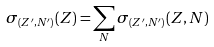Convert formula to latex. <formula><loc_0><loc_0><loc_500><loc_500>\sigma _ { ( Z ^ { \prime } , N ^ { \prime } ) } ( Z ) = \sum _ { N } { \sigma _ { ( Z ^ { \prime } , N ^ { \prime } ) } ( Z , N ) }</formula> 